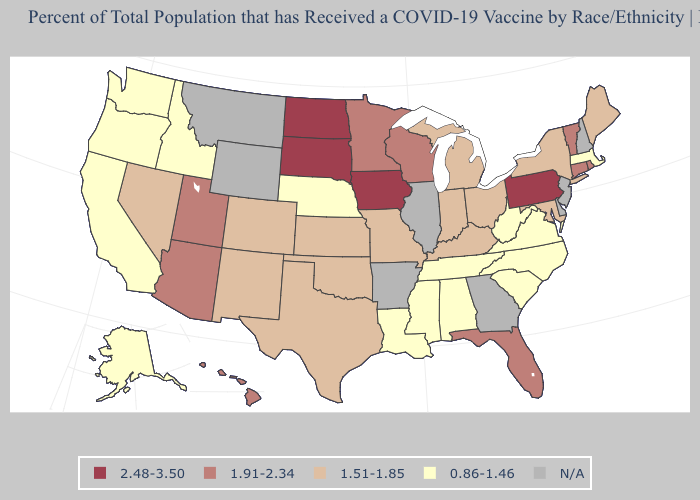Among the states that border Nevada , does Utah have the highest value?
Keep it brief. Yes. Does Nebraska have the lowest value in the MidWest?
Keep it brief. Yes. Does Washington have the highest value in the West?
Quick response, please. No. Does Hawaii have the highest value in the USA?
Be succinct. No. Name the states that have a value in the range 1.51-1.85?
Give a very brief answer. Colorado, Indiana, Kansas, Kentucky, Maine, Maryland, Michigan, Missouri, Nevada, New Mexico, New York, Ohio, Oklahoma, Texas. Which states hav the highest value in the MidWest?
Concise answer only. Iowa, North Dakota, South Dakota. Does Indiana have the highest value in the USA?
Short answer required. No. Does the first symbol in the legend represent the smallest category?
Answer briefly. No. How many symbols are there in the legend?
Short answer required. 5. Name the states that have a value in the range 1.51-1.85?
Give a very brief answer. Colorado, Indiana, Kansas, Kentucky, Maine, Maryland, Michigan, Missouri, Nevada, New Mexico, New York, Ohio, Oklahoma, Texas. What is the value of Mississippi?
Give a very brief answer. 0.86-1.46. Among the states that border Nebraska , does Iowa have the lowest value?
Quick response, please. No. What is the lowest value in states that border Florida?
Keep it brief. 0.86-1.46. What is the highest value in the USA?
Give a very brief answer. 2.48-3.50. 